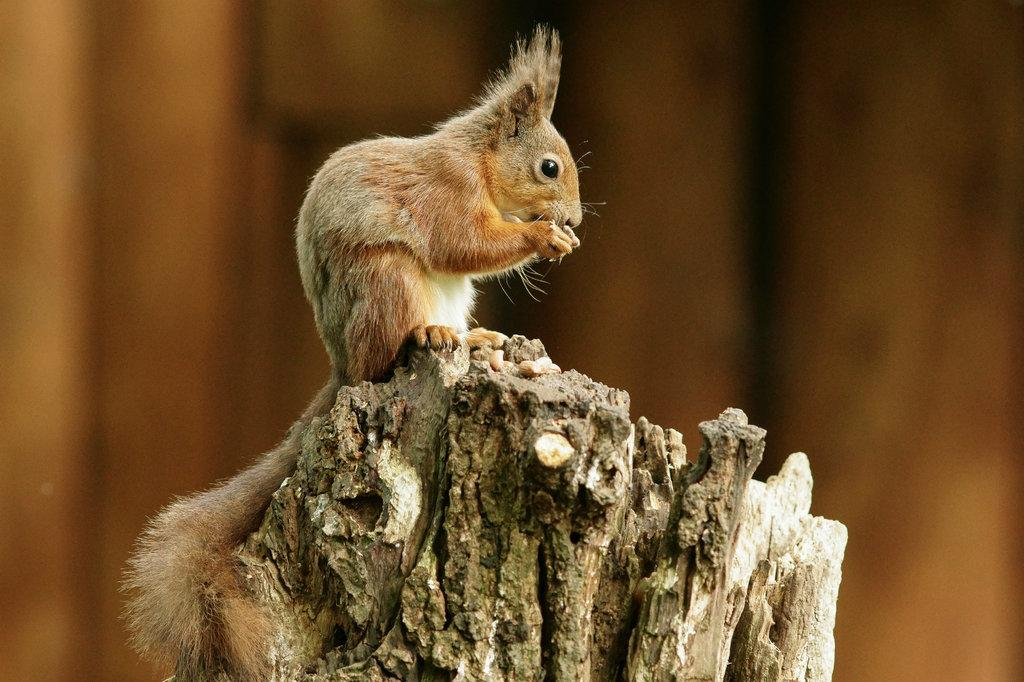What animal is present in the image? There is a squirrel in the image. What is the squirrel sitting on? The squirrel is on a wooden truck. Can you describe the background of the image? The background of the image is blurry. What type of music does the squirrel play on the wooden truck? There is no indication in the image that the squirrel is playing any music, as the image only shows a squirrel sitting on a wooden truck with a blurry background. 